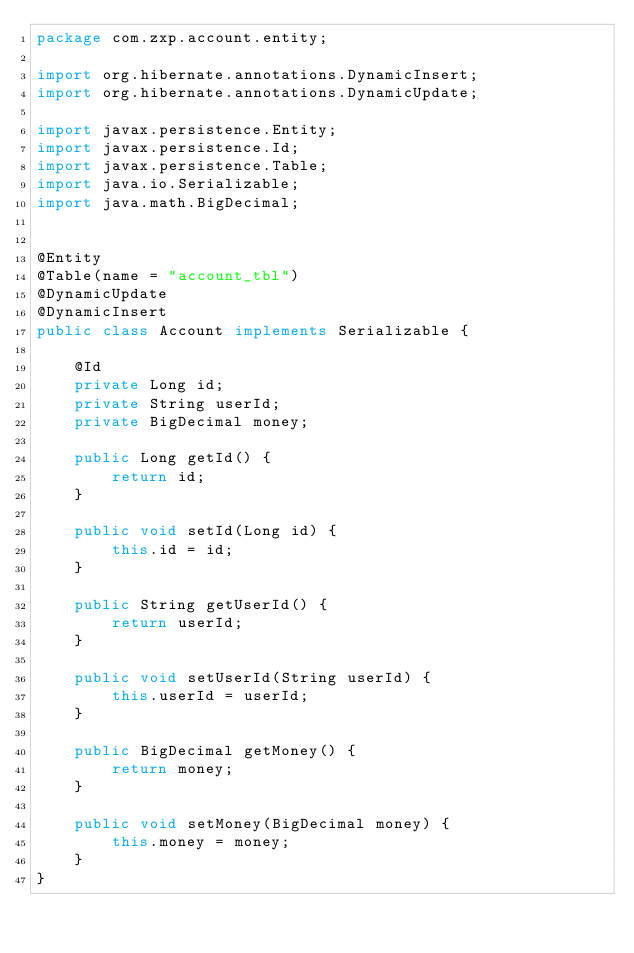<code> <loc_0><loc_0><loc_500><loc_500><_Java_>package com.zxp.account.entity;

import org.hibernate.annotations.DynamicInsert;
import org.hibernate.annotations.DynamicUpdate;

import javax.persistence.Entity;
import javax.persistence.Id;
import javax.persistence.Table;
import java.io.Serializable;
import java.math.BigDecimal;


@Entity
@Table(name = "account_tbl")
@DynamicUpdate
@DynamicInsert
public class Account implements Serializable {

    @Id
    private Long id;
    private String userId;
    private BigDecimal money;

    public Long getId() {
        return id;
    }

    public void setId(Long id) {
        this.id = id;
    }

    public String getUserId() {
        return userId;
    }

    public void setUserId(String userId) {
        this.userId = userId;
    }

    public BigDecimal getMoney() {
        return money;
    }

    public void setMoney(BigDecimal money) {
        this.money = money;
    }
}
</code> 